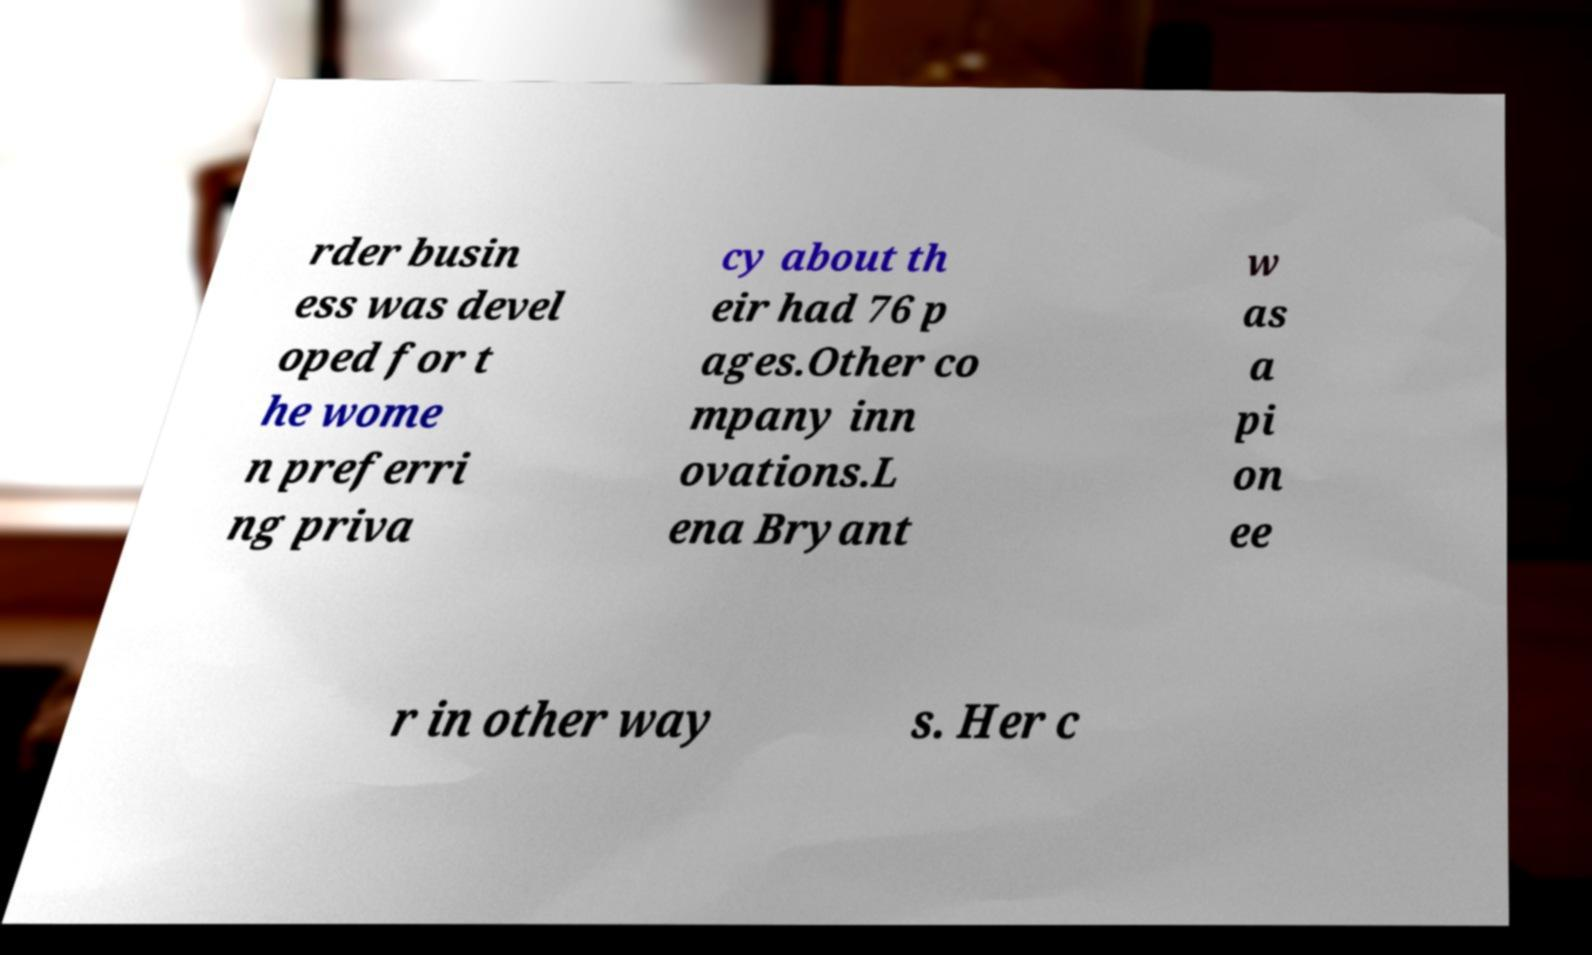I need the written content from this picture converted into text. Can you do that? rder busin ess was devel oped for t he wome n preferri ng priva cy about th eir had 76 p ages.Other co mpany inn ovations.L ena Bryant w as a pi on ee r in other way s. Her c 